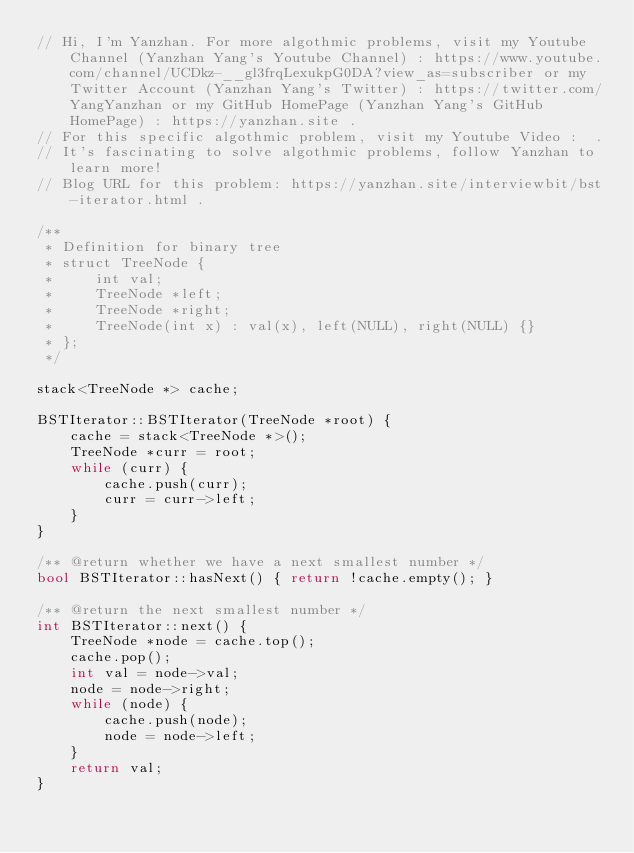<code> <loc_0><loc_0><loc_500><loc_500><_C++_>// Hi, I'm Yanzhan. For more algothmic problems, visit my Youtube Channel (Yanzhan Yang's Youtube Channel) : https://www.youtube.com/channel/UCDkz-__gl3frqLexukpG0DA?view_as=subscriber or my Twitter Account (Yanzhan Yang's Twitter) : https://twitter.com/YangYanzhan or my GitHub HomePage (Yanzhan Yang's GitHub HomePage) : https://yanzhan.site .
// For this specific algothmic problem, visit my Youtube Video :  .
// It's fascinating to solve algothmic problems, follow Yanzhan to learn more!
// Blog URL for this problem: https://yanzhan.site/interviewbit/bst-iterator.html .

/**
 * Definition for binary tree
 * struct TreeNode {
 *     int val;
 *     TreeNode *left;
 *     TreeNode *right;
 *     TreeNode(int x) : val(x), left(NULL), right(NULL) {}
 * };
 */

stack<TreeNode *> cache;

BSTIterator::BSTIterator(TreeNode *root) {
    cache = stack<TreeNode *>();
    TreeNode *curr = root;
    while (curr) {
        cache.push(curr);
        curr = curr->left;
    }
}

/** @return whether we have a next smallest number */
bool BSTIterator::hasNext() { return !cache.empty(); }

/** @return the next smallest number */
int BSTIterator::next() {
    TreeNode *node = cache.top();
    cache.pop();
    int val = node->val;
    node = node->right;
    while (node) {
        cache.push(node);
        node = node->left;
    }
    return val;
}
</code> 